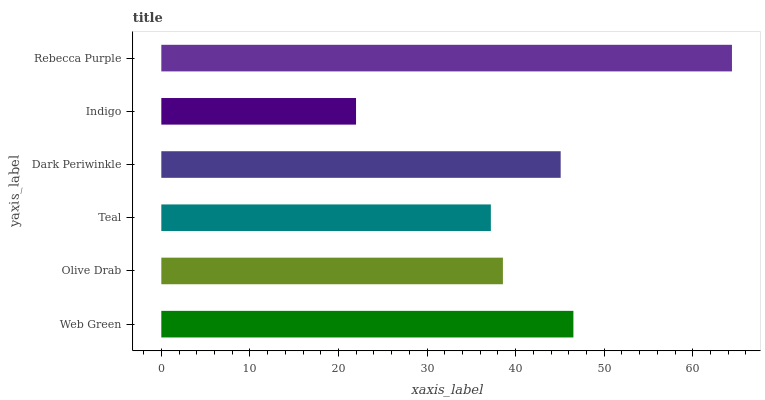Is Indigo the minimum?
Answer yes or no. Yes. Is Rebecca Purple the maximum?
Answer yes or no. Yes. Is Olive Drab the minimum?
Answer yes or no. No. Is Olive Drab the maximum?
Answer yes or no. No. Is Web Green greater than Olive Drab?
Answer yes or no. Yes. Is Olive Drab less than Web Green?
Answer yes or no. Yes. Is Olive Drab greater than Web Green?
Answer yes or no. No. Is Web Green less than Olive Drab?
Answer yes or no. No. Is Dark Periwinkle the high median?
Answer yes or no. Yes. Is Olive Drab the low median?
Answer yes or no. Yes. Is Olive Drab the high median?
Answer yes or no. No. Is Indigo the low median?
Answer yes or no. No. 